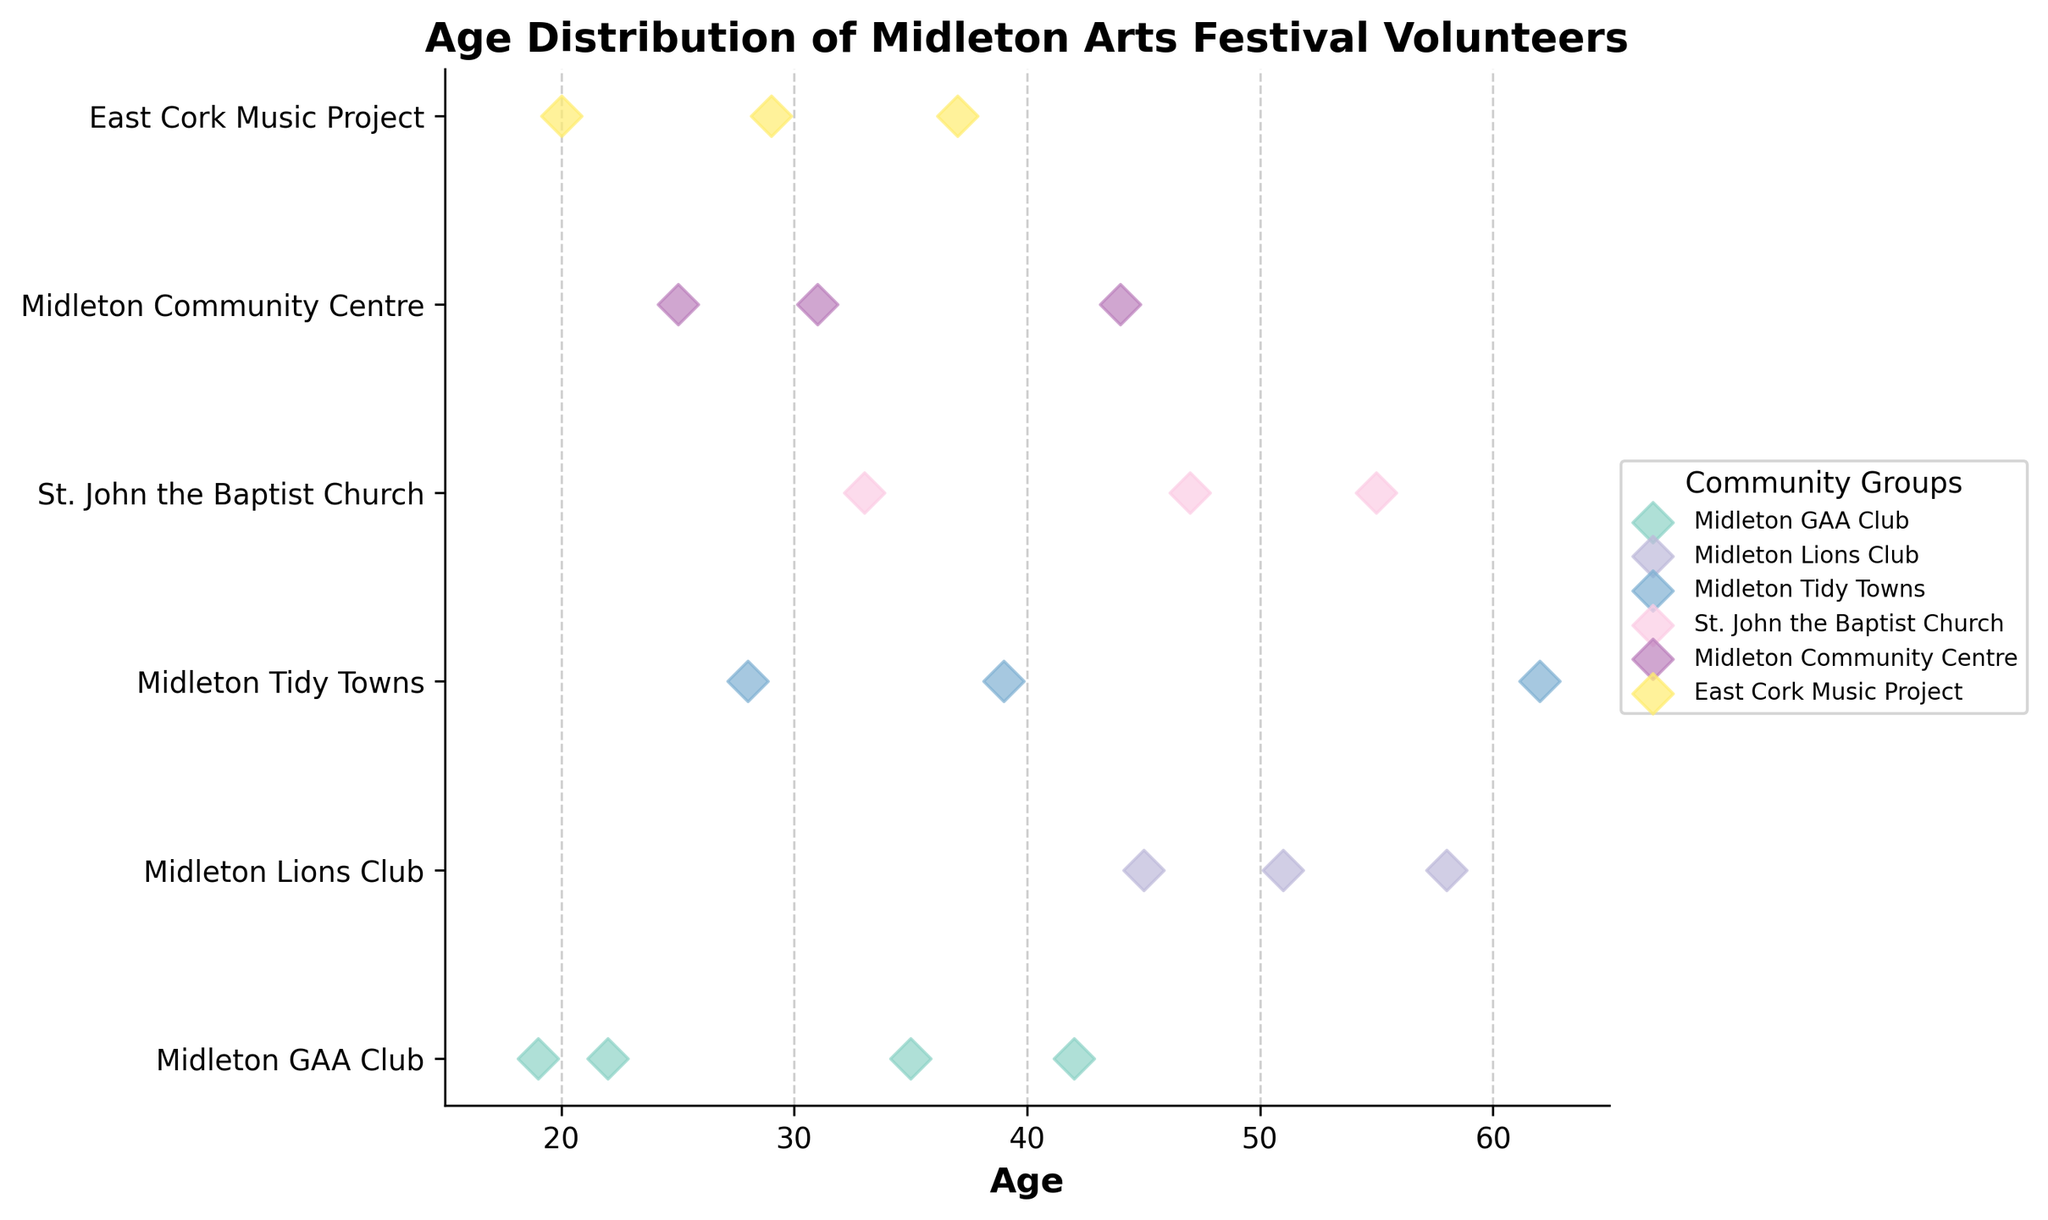Which group has the smallest range of ages? The Midleton GAA Club has volunteers aged between 19 and 42, giving a range of 23 years. Midleton Lions Club has a range of 13 years (45-58), Midleton Tidy Towns has a range of 34 years (28-62), St. John the Baptist Church has a range of 22 years (33-55), Midleton Community Centre has a range of 19 years (25-44), and East Cork Music Project has a range of 17 years (20-37). The Midleton Lions Club has the smallest range of ages.
Answer: Midleton Lions Club Which community group has the oldest volunteer? The oldest volunteer is 62 years old and belongs to Midleton Tidy Towns.
Answer: Midleton Tidy Towns What is the average age of volunteers in the East Cork Music Project group? The ages in the East Cork Music Project group are 20, 29, and 37. Adding these up gives 86. Dividing by the number of volunteers (3) gives an average age of 28.7 years.
Answer: 28.7 years How many data points are there for the Midleton GAA Club? There are four visible markers on the strip plot for the Midleton GAA Club group.
Answer: 4 Compare the median ages of Midleton Tidy Towns and St. John the Baptist Church volunteers. Which is higher? The ages for Midleton Tidy Towns are 28, 39, and 62. The median is 39. For St. John the Baptist Church, the ages are 33, 47, and 55. The median is 47. Thus, the median age of St. John the Baptist Church volunteers is higher.
Answer: St. John the Baptist Church Which group has the most volunteers older than 50? Midleton Lions Club has two volunteers older than 50 (51 and 58). Other groups have either one or none.
Answer: Midleton Lions Club What is the range of ages for volunteers in Midleton Tidy Towns? Midleton Tidy Towns has volunteers aged 28, 39, and 62, giving a range of 34 years (62-28).
Answer: 34 years Which group has the most diverse age distribution? The most diverse age distribution is determined by the range. Midleton Tidy Towns has the largest range (34 years), indicating the most diverse age distribution.
Answer: Midleton Tidy Towns What is the median age of volunteers in the Midleton GAA Club group? The ages for Midleton GAA Club are 19, 22, 35, and 42. The median of an even number of points is the average of the two middle values. Here, it is (22+35)/2 = 28.5.
Answer: 28.5 years 